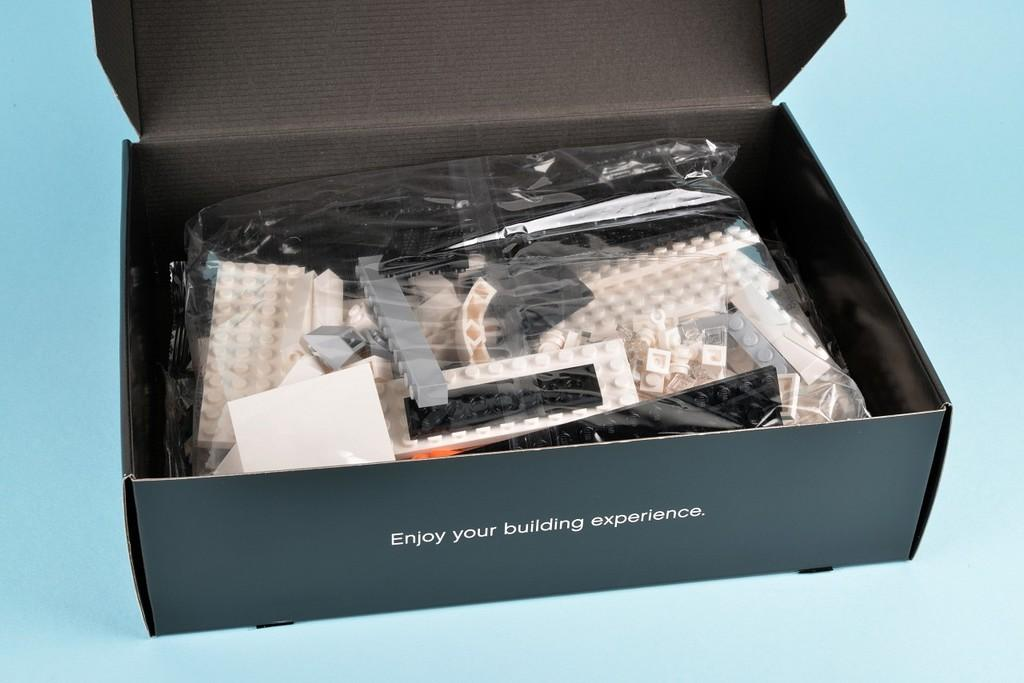<image>
Offer a succinct explanation of the picture presented. a box of building bricks reading Enjoy Your Building Experience 